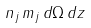Convert formula to latex. <formula><loc_0><loc_0><loc_500><loc_500>n _ { j } \, m _ { j } \, d \Omega \, d z</formula> 